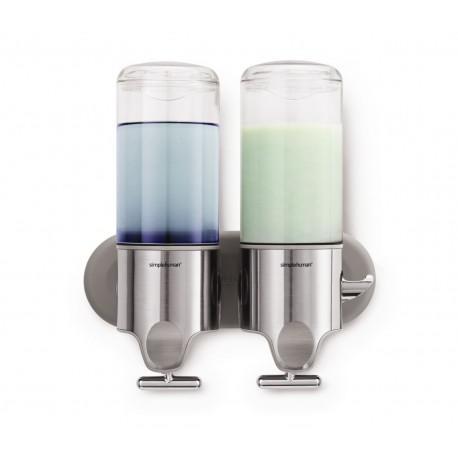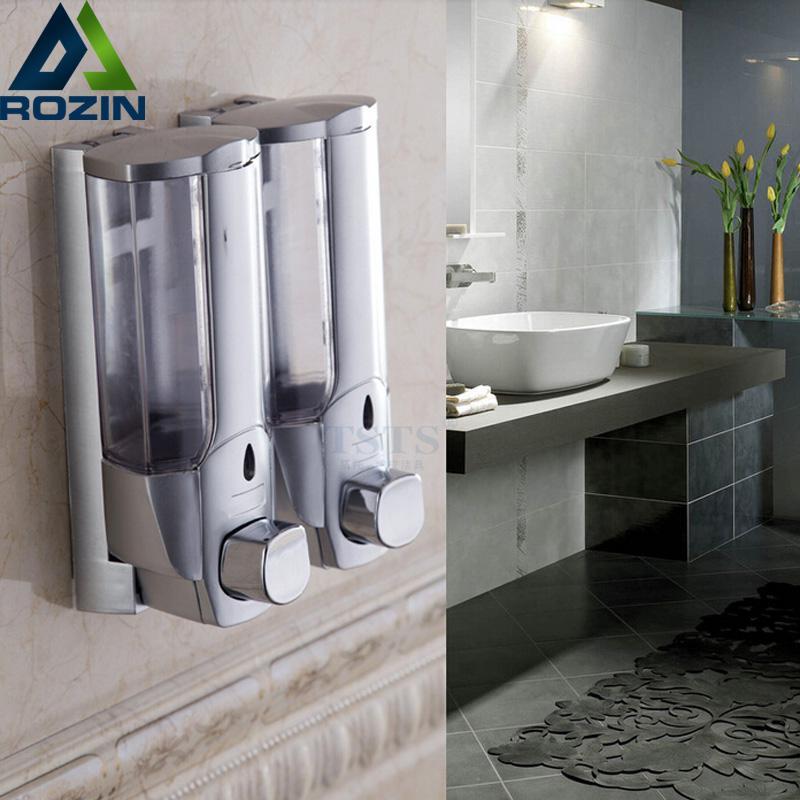The first image is the image on the left, the second image is the image on the right. Examine the images to the left and right. Is the description "There are four soap dispensers in total." accurate? Answer yes or no. Yes. The first image is the image on the left, the second image is the image on the right. Considering the images on both sides, is "An image shows at least two side-by-side dispensers that feature a chrome T-shaped bar underneath." valid? Answer yes or no. Yes. 